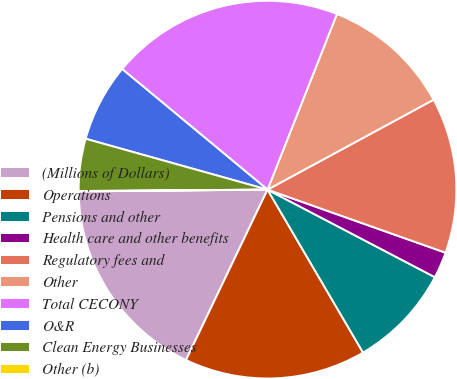<chart> <loc_0><loc_0><loc_500><loc_500><pie_chart><fcel>(Millions of Dollars)<fcel>Operations<fcel>Pensions and other<fcel>Health care and other benefits<fcel>Regulatory fees and<fcel>Other<fcel>Total CECONY<fcel>O&R<fcel>Clean Energy Businesses<fcel>Other (b)<nl><fcel>17.75%<fcel>15.54%<fcel>8.89%<fcel>2.25%<fcel>13.32%<fcel>11.11%<fcel>19.97%<fcel>6.68%<fcel>4.46%<fcel>0.03%<nl></chart> 